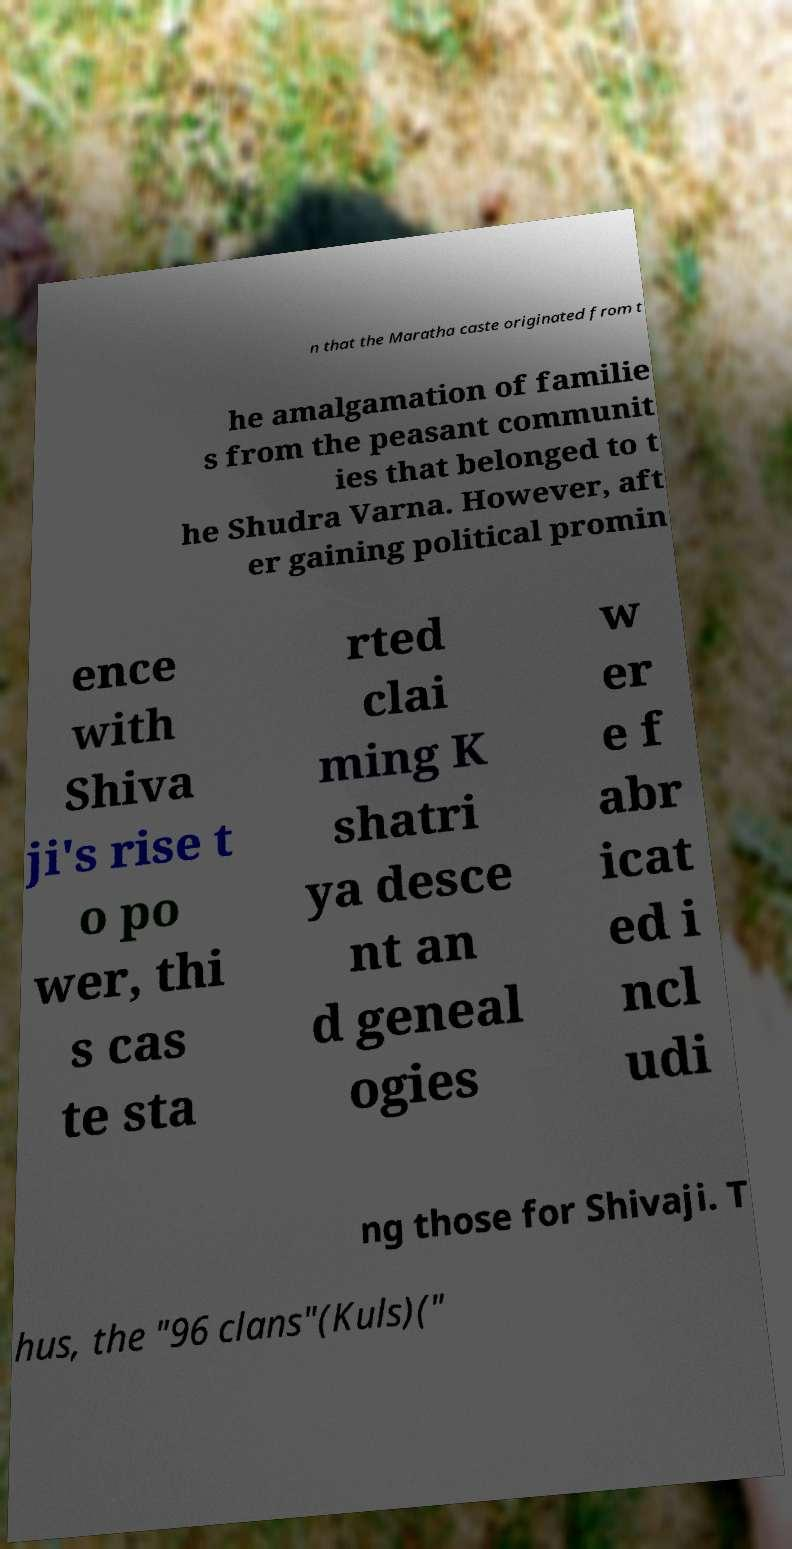Could you assist in decoding the text presented in this image and type it out clearly? n that the Maratha caste originated from t he amalgamation of familie s from the peasant communit ies that belonged to t he Shudra Varna. However, aft er gaining political promin ence with Shiva ji's rise t o po wer, thi s cas te sta rted clai ming K shatri ya desce nt an d geneal ogies w er e f abr icat ed i ncl udi ng those for Shivaji. T hus, the "96 clans"(Kuls)(" 